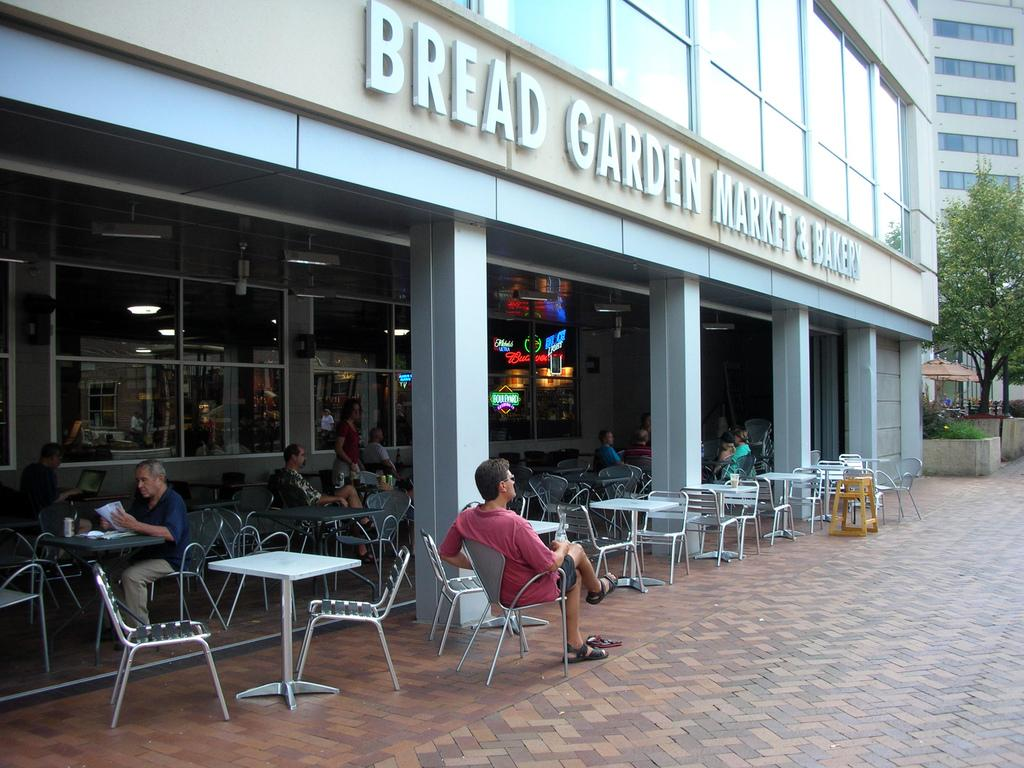What type of structures can be seen in the image? There are buildings in the image. What other natural elements are present in the image? There are trees in the image. What type of furniture is visible at the bottom of the image? Tables and chairs are present at the bottom of the image. What are the people in the image doing? Some people are sitting in the chairs, while others are standing. What additional piece of furniture can be seen in the image? There is a stool in the image. What type of silver object is being used by the writer in the image? There is no writer or silver object present in the image. Where is the shelf located in the image? There is no shelf present in the image. 